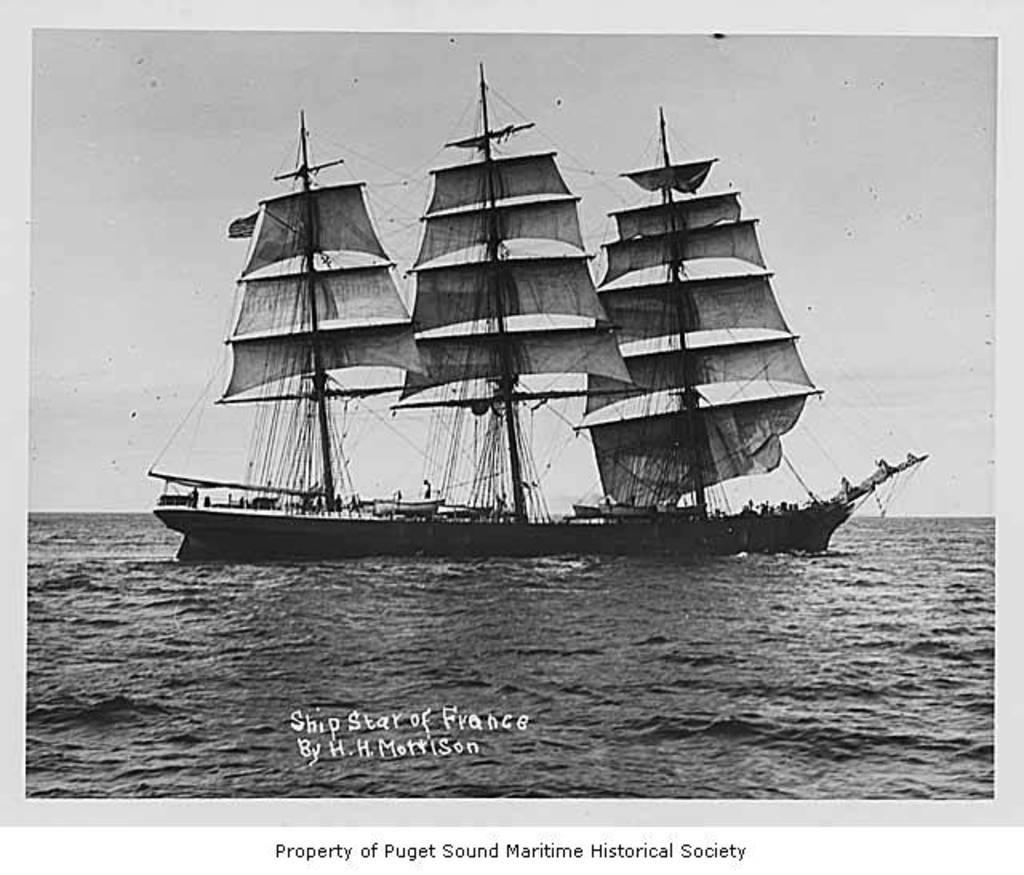In one or two sentences, can you explain what this image depicts? This is an edited image with the borders. In the center of this picture we can see a boat in the water body. In the background we can see the sky. At the bottom we can see the text on the image and we can see some other objects. 